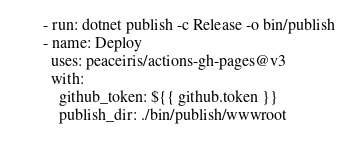<code> <loc_0><loc_0><loc_500><loc_500><_YAML_>
      - run: dotnet publish -c Release -o bin/publish
      - name: Deploy
        uses: peaceiris/actions-gh-pages@v3
        with:
          github_token: ${{ github.token }}
          publish_dir: ./bin/publish/wwwroot
</code> 